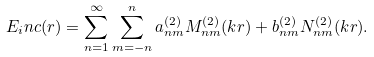<formula> <loc_0><loc_0><loc_500><loc_500>E _ { i } n c ( r ) = \sum _ { n = 1 } ^ { \infty } \sum _ { m = - n } ^ { n } a ^ { ( 2 ) } _ { n m } M _ { n m } ^ { ( 2 ) } ( k r ) + b ^ { ( 2 ) } _ { n m } N _ { n m } ^ { ( 2 ) } ( k r ) .</formula> 